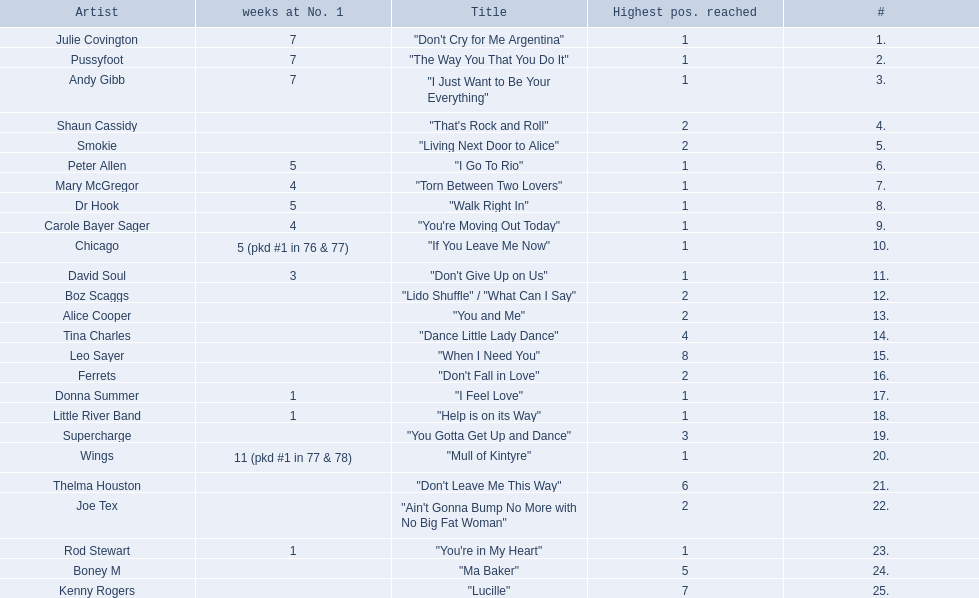Who had the one of the least weeks at number one? Rod Stewart. Who had no week at number one? Shaun Cassidy. Who had the highest number of weeks at number one? Wings. 